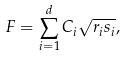Convert formula to latex. <formula><loc_0><loc_0><loc_500><loc_500>F = \sum _ { i = 1 } ^ { d } C _ { i } \sqrt { r _ { i } s _ { i } } ,</formula> 